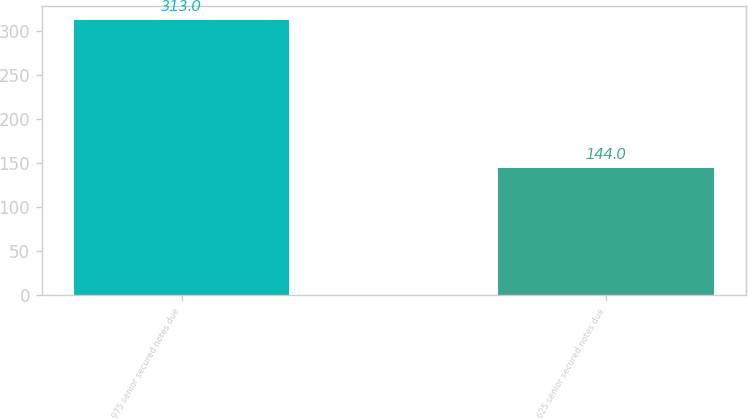Convert chart to OTSL. <chart><loc_0><loc_0><loc_500><loc_500><bar_chart><fcel>975 senior secured notes due<fcel>625 senior secured notes due<nl><fcel>313<fcel>144<nl></chart> 